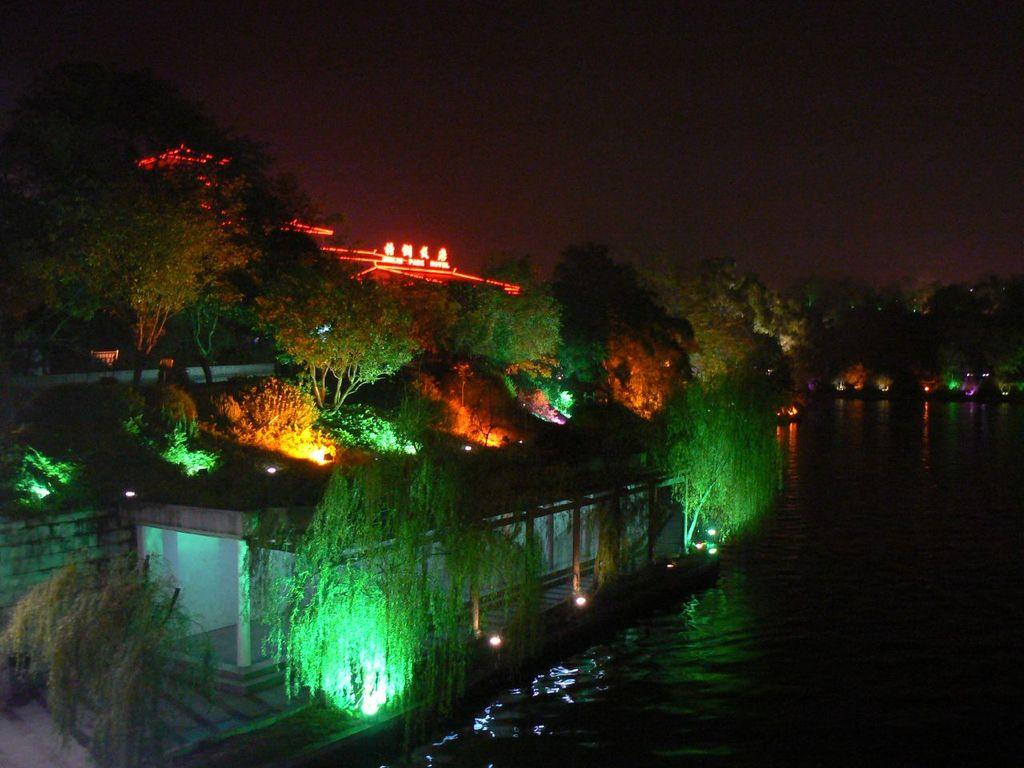What type of location is shown in the image? The image depicts a city. What natural element can be seen in the image? There is water visible in the image. What artificial elements are present in the image? There are lights in the image. What type of vegetation is present in the image? There are trees in the image. What is visible in the background of the image? The sky is visible in the background of the image. How many ants can be seen crawling on the carpenter in the image? There are no ants or carpenters present in the image. 